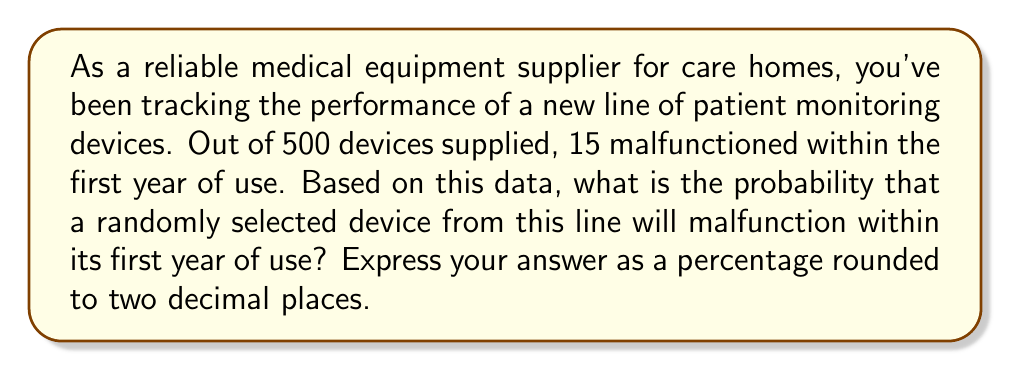Solve this math problem. To solve this problem, we need to use the concept of probability based on observed frequency. The probability of an event is calculated by dividing the number of favorable outcomes by the total number of possible outcomes.

Let's define our variables:
$n$ = total number of devices = 500
$m$ = number of malfunctioning devices = 15

The probability $p$ of a device malfunctioning within the first year is:

$$p = \frac{m}{n} = \frac{15}{500}$$

To convert this to a percentage, we multiply by 100:

$$p(\%) = \frac{15}{500} \times 100 = 0.03 \times 100 = 3\%$$

Rounding to two decimal places, we get 3.00%.

This means that based on the observed data, there is a 3.00% chance that a randomly selected device from this line will malfunction within its first year of use.
Answer: 3.00% 